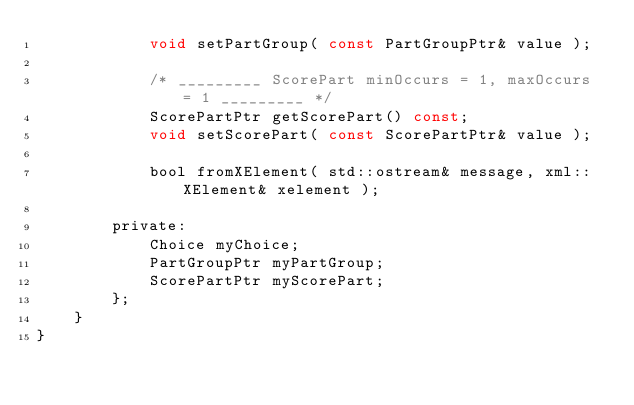Convert code to text. <code><loc_0><loc_0><loc_500><loc_500><_C_>            void setPartGroup( const PartGroupPtr& value );

            /* _________ ScorePart minOccurs = 1, maxOccurs = 1 _________ */
            ScorePartPtr getScorePart() const;
            void setScorePart( const ScorePartPtr& value );

            bool fromXElement( std::ostream& message, xml::XElement& xelement );
            
        private:
            Choice myChoice;
            PartGroupPtr myPartGroup;
            ScorePartPtr myScorePart;
        };
    }
}
</code> 